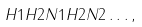<formula> <loc_0><loc_0><loc_500><loc_500>H 1 H 2 N 1 H 2 N 2 \dots ,</formula> 